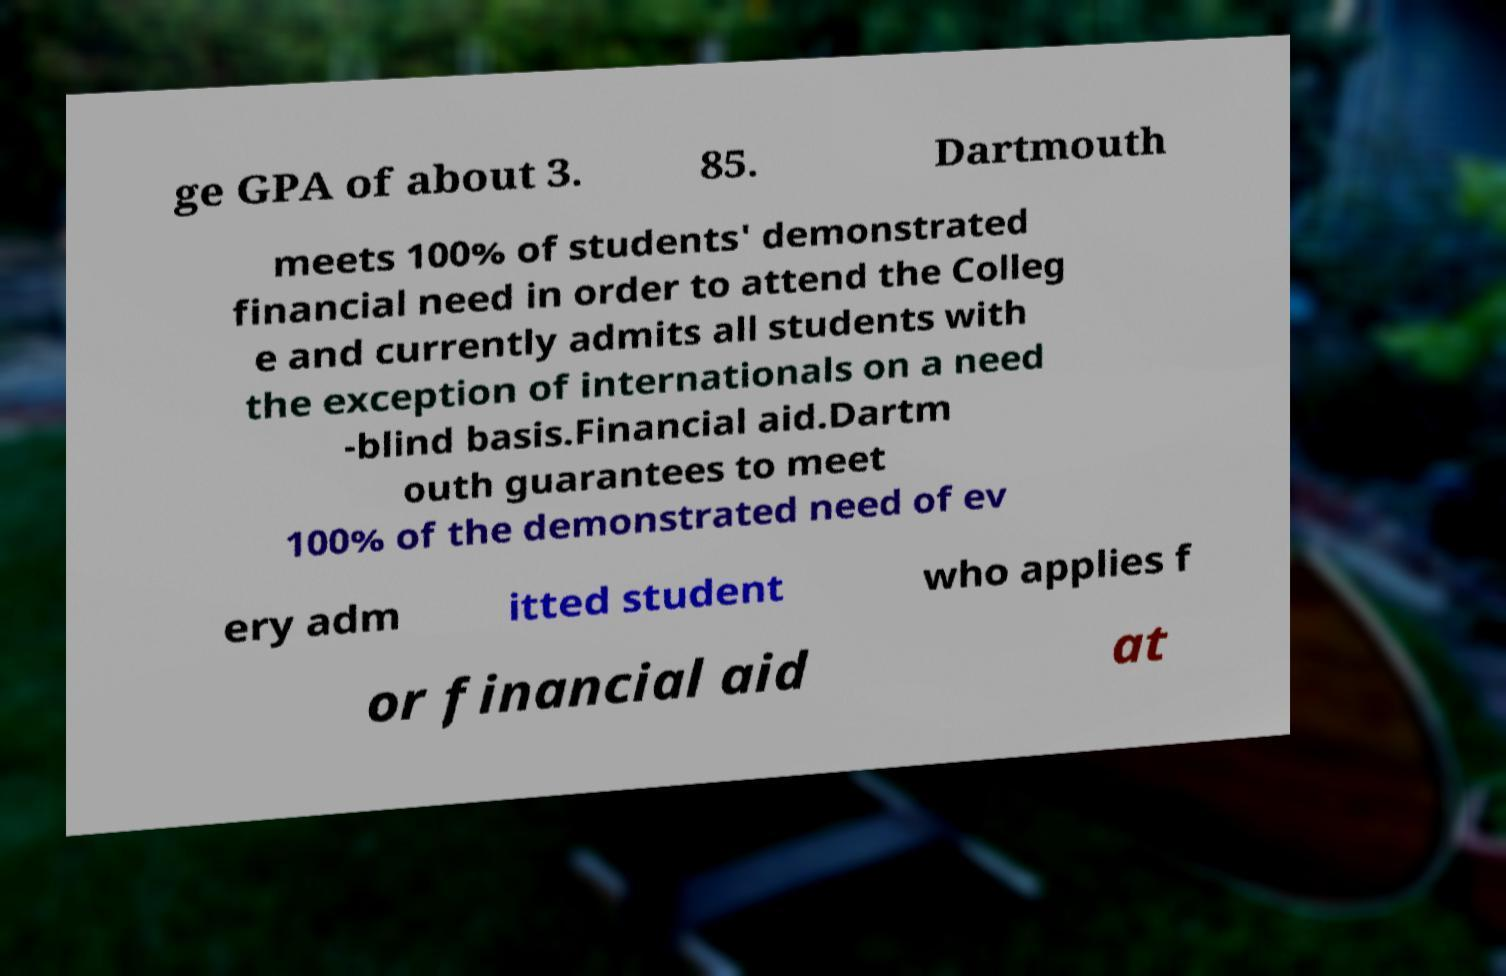Can you read and provide the text displayed in the image?This photo seems to have some interesting text. Can you extract and type it out for me? ge GPA of about 3. 85. Dartmouth meets 100% of students' demonstrated financial need in order to attend the Colleg e and currently admits all students with the exception of internationals on a need -blind basis.Financial aid.Dartm outh guarantees to meet 100% of the demonstrated need of ev ery adm itted student who applies f or financial aid at 